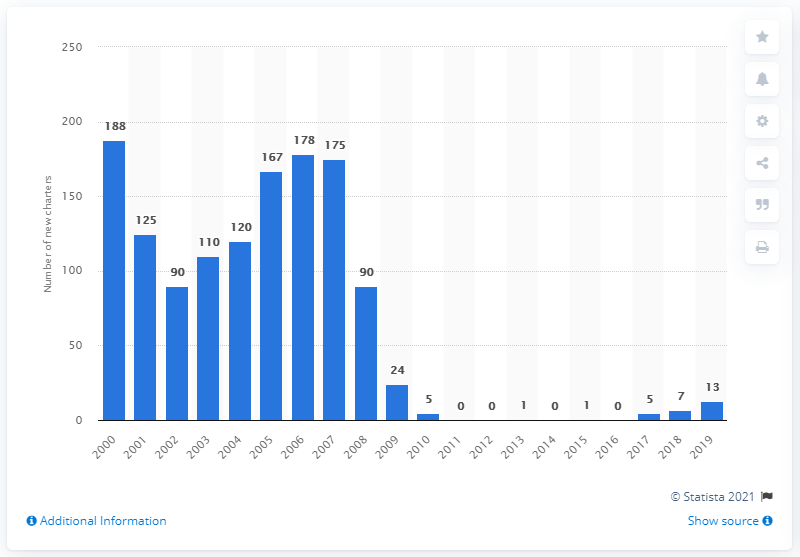Specify some key components in this picture. In 2019, there were 13 new FDIC-insured commercial bank charters in the United States. 